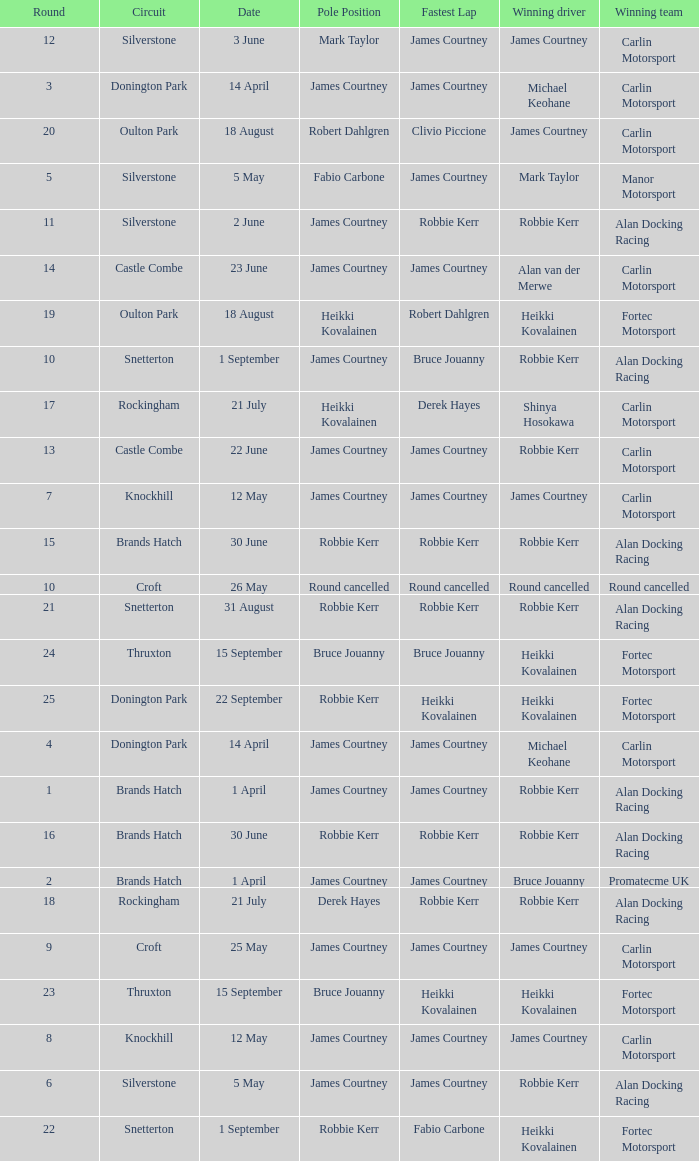What is every date of Mark Taylor as winning driver? 5 May. 